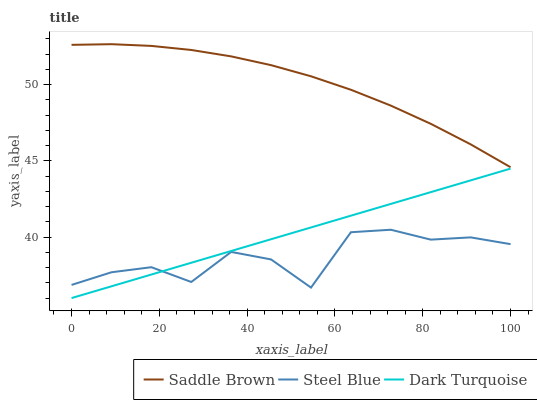Does Steel Blue have the minimum area under the curve?
Answer yes or no. Yes. Does Saddle Brown have the maximum area under the curve?
Answer yes or no. Yes. Does Saddle Brown have the minimum area under the curve?
Answer yes or no. No. Does Steel Blue have the maximum area under the curve?
Answer yes or no. No. Is Dark Turquoise the smoothest?
Answer yes or no. Yes. Is Steel Blue the roughest?
Answer yes or no. Yes. Is Saddle Brown the smoothest?
Answer yes or no. No. Is Saddle Brown the roughest?
Answer yes or no. No. Does Dark Turquoise have the lowest value?
Answer yes or no. Yes. Does Steel Blue have the lowest value?
Answer yes or no. No. Does Saddle Brown have the highest value?
Answer yes or no. Yes. Does Steel Blue have the highest value?
Answer yes or no. No. Is Dark Turquoise less than Saddle Brown?
Answer yes or no. Yes. Is Saddle Brown greater than Dark Turquoise?
Answer yes or no. Yes. Does Steel Blue intersect Dark Turquoise?
Answer yes or no. Yes. Is Steel Blue less than Dark Turquoise?
Answer yes or no. No. Is Steel Blue greater than Dark Turquoise?
Answer yes or no. No. Does Dark Turquoise intersect Saddle Brown?
Answer yes or no. No. 